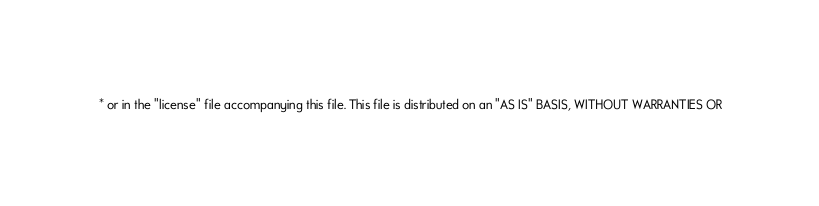Convert code to text. <code><loc_0><loc_0><loc_500><loc_500><_Java_> * or in the "license" file accompanying this file. This file is distributed on an "AS IS" BASIS, WITHOUT WARRANTIES OR</code> 